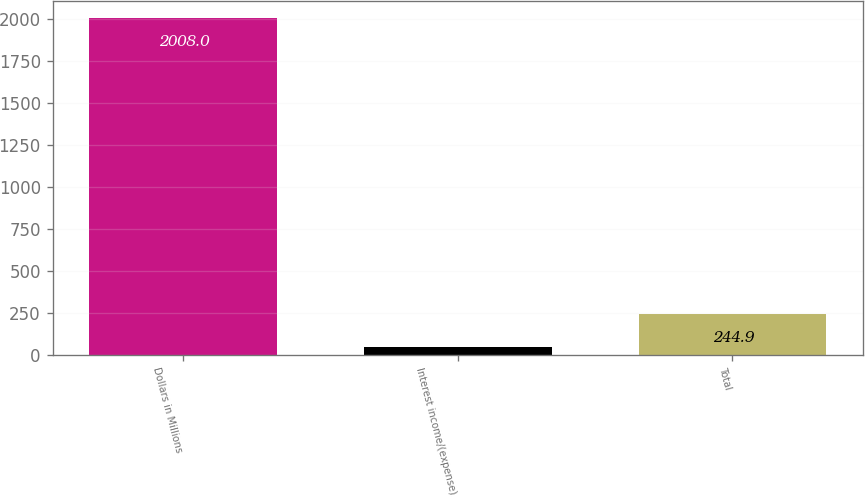Convert chart to OTSL. <chart><loc_0><loc_0><loc_500><loc_500><bar_chart><fcel>Dollars in Millions<fcel>Interest income/(expense)<fcel>Total<nl><fcel>2008<fcel>49<fcel>244.9<nl></chart> 